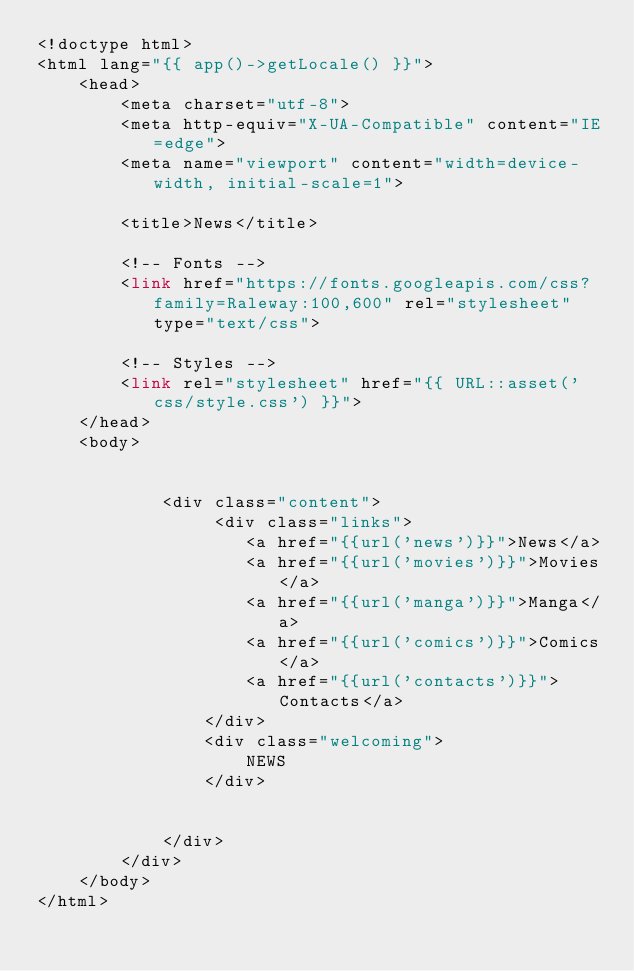<code> <loc_0><loc_0><loc_500><loc_500><_PHP_><!doctype html>
<html lang="{{ app()->getLocale() }}">
    <head>
        <meta charset="utf-8">
        <meta http-equiv="X-UA-Compatible" content="IE=edge">
        <meta name="viewport" content="width=device-width, initial-scale=1">

        <title>News</title>

        <!-- Fonts -->
        <link href="https://fonts.googleapis.com/css?family=Raleway:100,600" rel="stylesheet" type="text/css">

        <!-- Styles -->
        <link rel="stylesheet" href="{{ URL::asset('css/style.css') }}">
    </head>
    <body>
       

            <div class="content">
                 <div class="links">
                    <a href="{{url('news')}}">News</a>
                    <a href="{{url('movies')}}">Movies</a>
                    <a href="{{url('manga')}}">Manga</a>
                    <a href="{{url('comics')}}">Comics</a>
                    <a href="{{url('contacts')}}">Contacts</a>
                </div>
                <div class="welcoming">
                    NEWS
                </div>

               
            </div>
        </div>
    </body>
</html></code> 